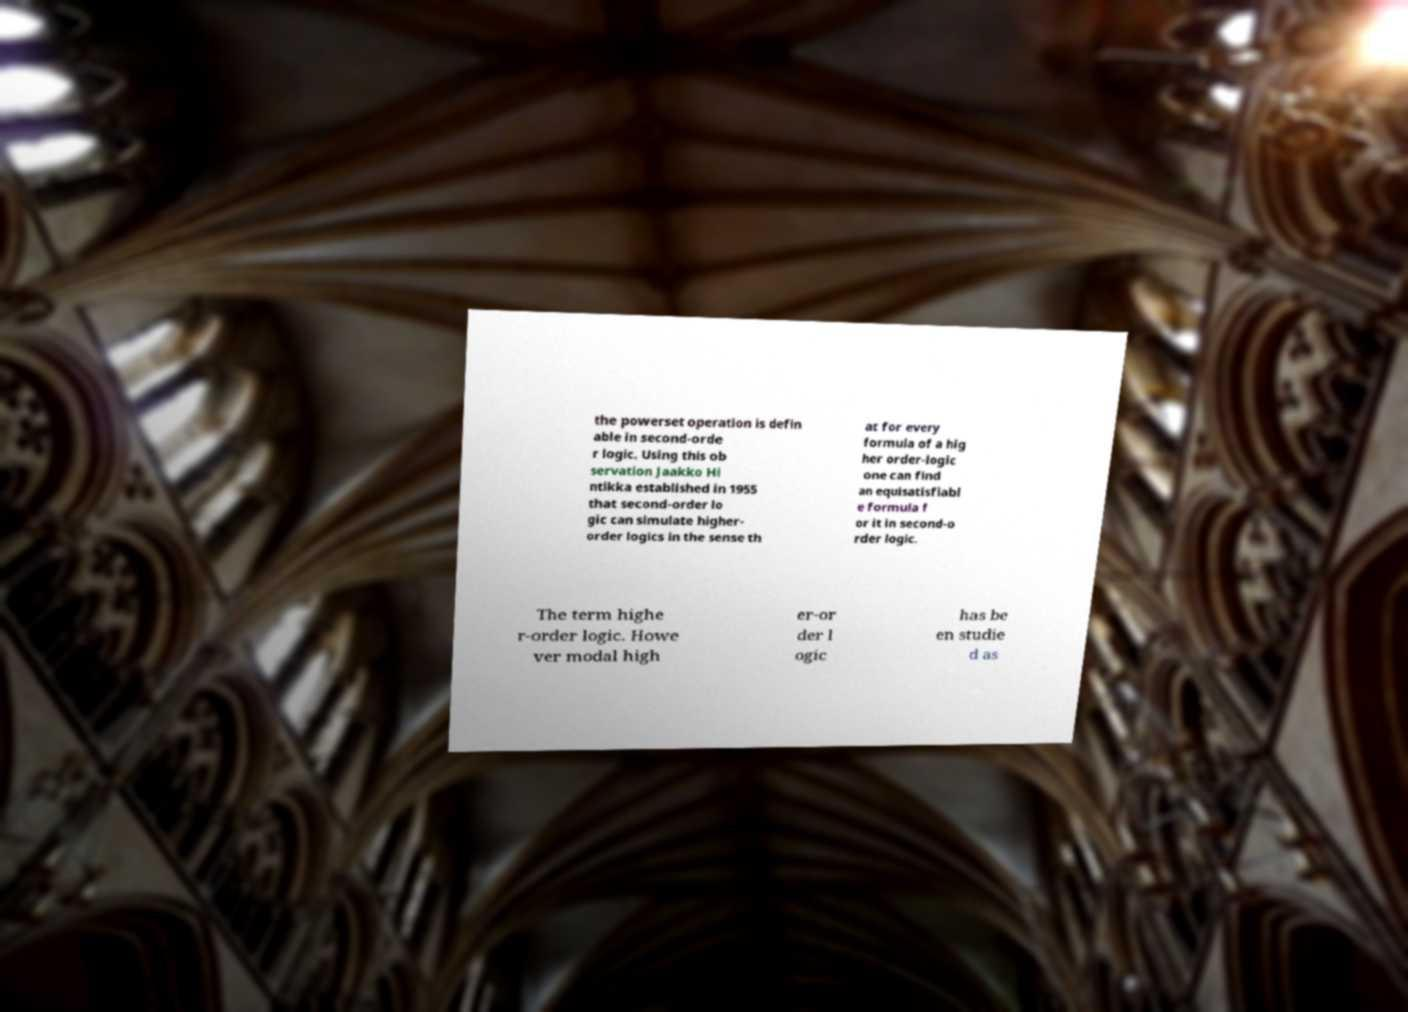What messages or text are displayed in this image? I need them in a readable, typed format. the powerset operation is defin able in second-orde r logic. Using this ob servation Jaakko Hi ntikka established in 1955 that second-order lo gic can simulate higher- order logics in the sense th at for every formula of a hig her order-logic one can find an equisatisfiabl e formula f or it in second-o rder logic. The term highe r-order logic. Howe ver modal high er-or der l ogic has be en studie d as 